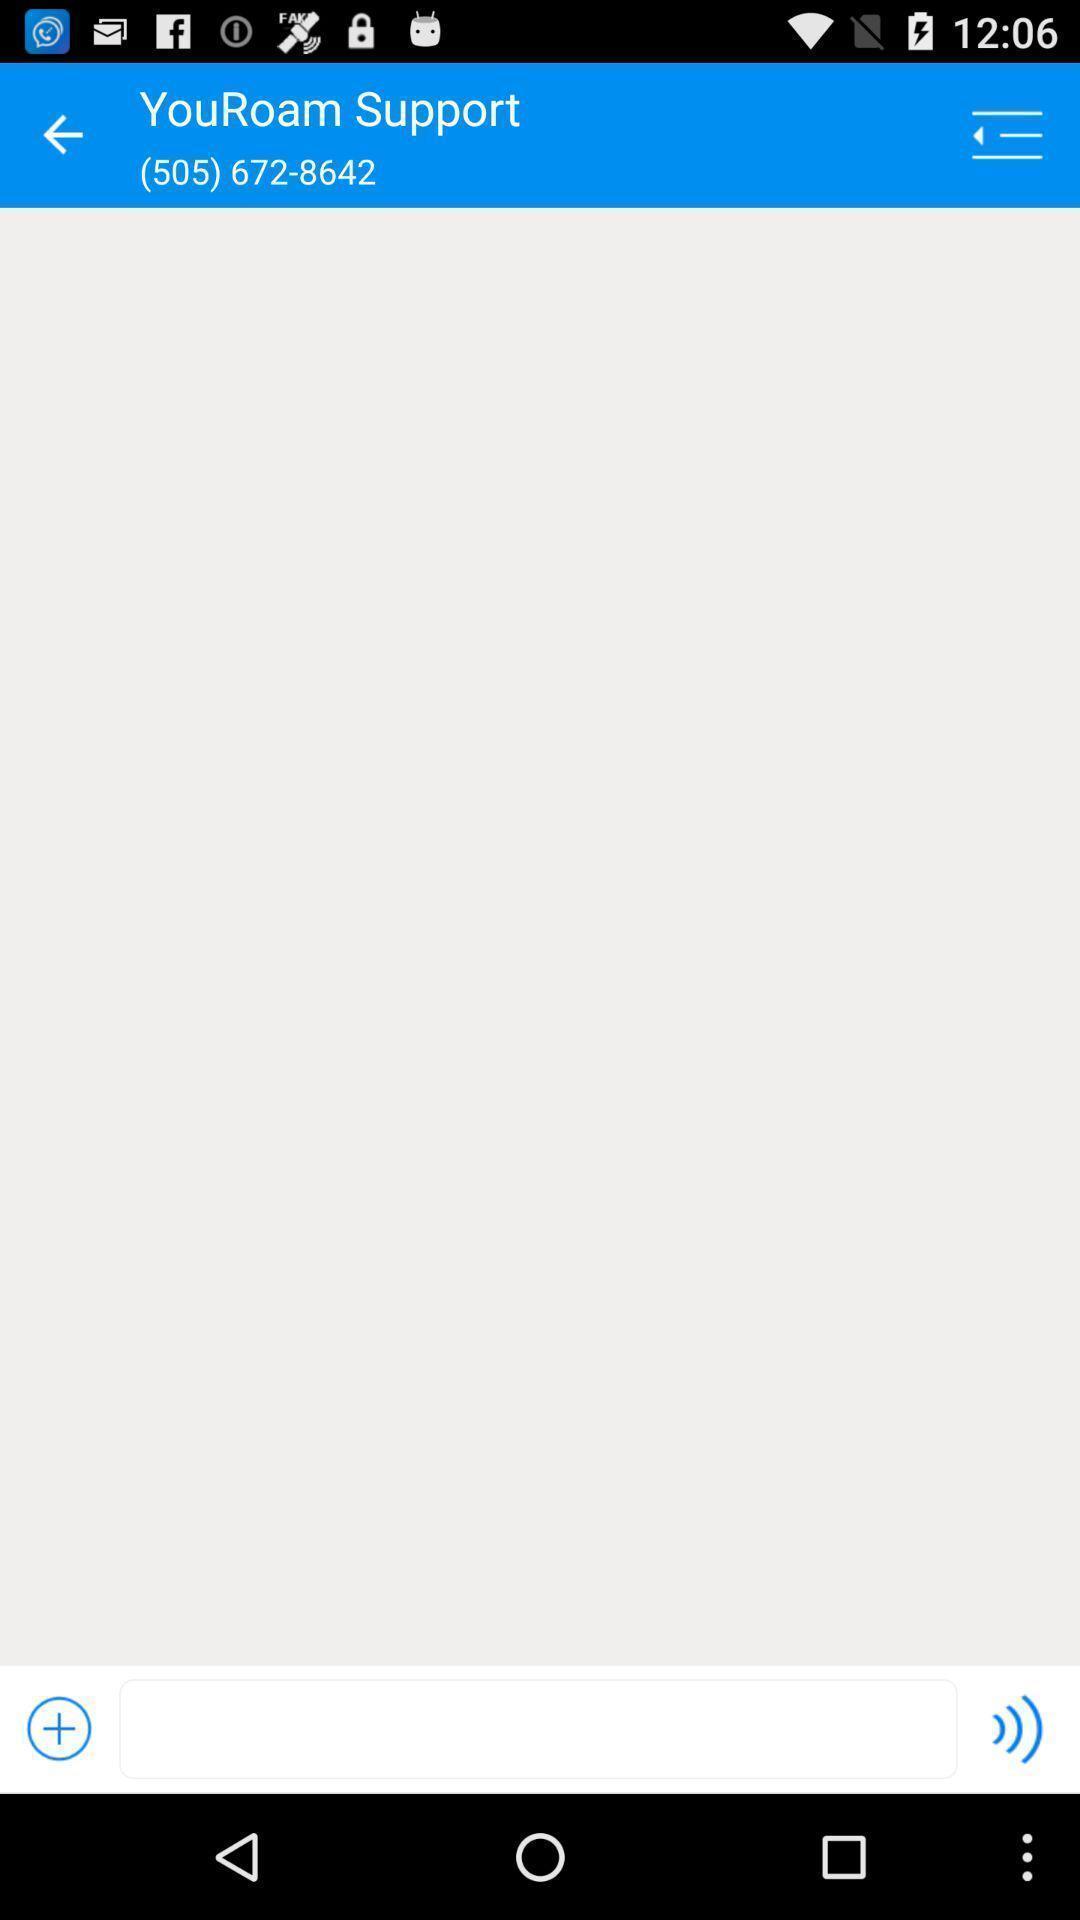Provide a textual representation of this image. Page showing a contact number on mobile. 